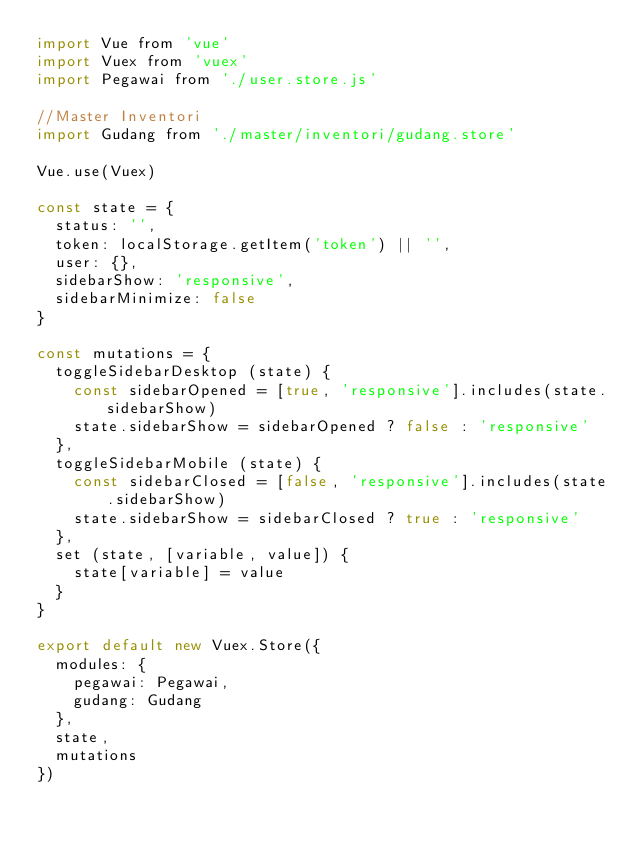Convert code to text. <code><loc_0><loc_0><loc_500><loc_500><_JavaScript_>import Vue from 'vue'
import Vuex from 'vuex'
import Pegawai from './user.store.js'

//Master Inventori
import Gudang from './master/inventori/gudang.store'

Vue.use(Vuex)

const state = {
  status: '',
  token: localStorage.getItem('token') || '',
  user: {},
  sidebarShow: 'responsive',
  sidebarMinimize: false
}

const mutations = {
  toggleSidebarDesktop (state) {
    const sidebarOpened = [true, 'responsive'].includes(state.sidebarShow)
    state.sidebarShow = sidebarOpened ? false : 'responsive'
  },
  toggleSidebarMobile (state) {
    const sidebarClosed = [false, 'responsive'].includes(state.sidebarShow)
    state.sidebarShow = sidebarClosed ? true : 'responsive'
  },
  set (state, [variable, value]) {
    state[variable] = value
  }
}

export default new Vuex.Store({
  modules: {
    pegawai: Pegawai,
    gudang: Gudang
  },
  state,
  mutations
})</code> 